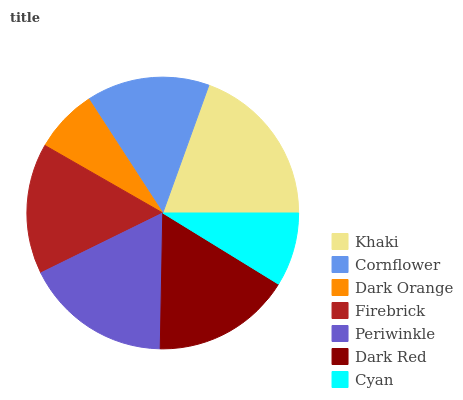Is Dark Orange the minimum?
Answer yes or no. Yes. Is Khaki the maximum?
Answer yes or no. Yes. Is Cornflower the minimum?
Answer yes or no. No. Is Cornflower the maximum?
Answer yes or no. No. Is Khaki greater than Cornflower?
Answer yes or no. Yes. Is Cornflower less than Khaki?
Answer yes or no. Yes. Is Cornflower greater than Khaki?
Answer yes or no. No. Is Khaki less than Cornflower?
Answer yes or no. No. Is Firebrick the high median?
Answer yes or no. Yes. Is Firebrick the low median?
Answer yes or no. Yes. Is Dark Orange the high median?
Answer yes or no. No. Is Cornflower the low median?
Answer yes or no. No. 